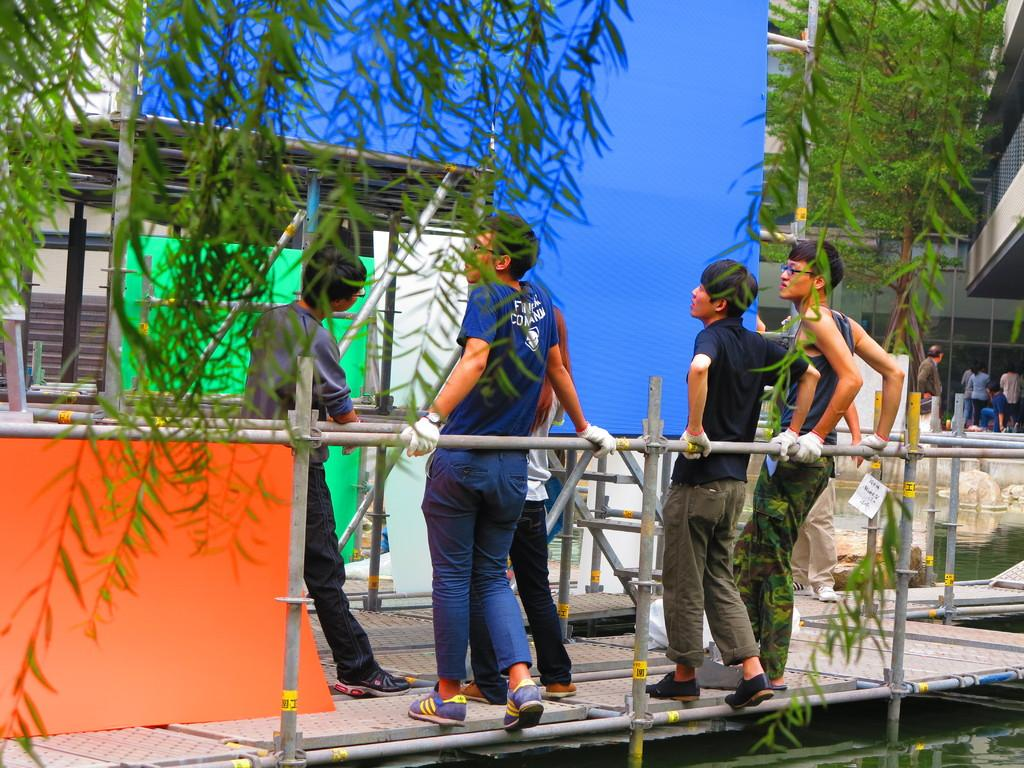Who or what can be seen in the image? There are people in the image. What structures are present in the image? There are poles, trees, a watershed, buildings, and other objects in the image. Can you describe the environment in the image? The image features a mix of natural elements, such as trees, and man-made structures, like buildings and poles. What type of teeth can be seen on the church in the image? There is no church present in the image, and therefore no teeth can be observed. 